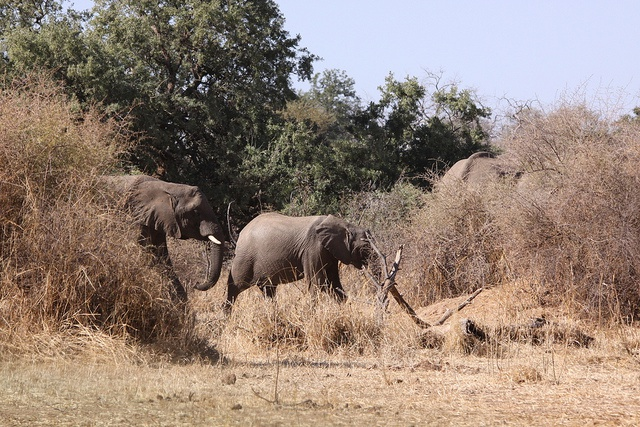Describe the objects in this image and their specific colors. I can see elephant in tan, black, gray, and darkgray tones, elephant in tan, black, and gray tones, and elephant in tan, darkgray, and gray tones in this image. 